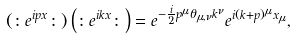Convert formula to latex. <formula><loc_0><loc_0><loc_500><loc_500>\left ( \colon e ^ { i p x } \colon \right ) \left ( \colon e ^ { i k x } \colon \right ) = e ^ { - \frac { i } { 2 } p ^ { \mu } \theta _ { \mu , \nu } k ^ { \nu } } e ^ { i ( k + p ) ^ { \mu } x _ { \mu } } ,</formula> 